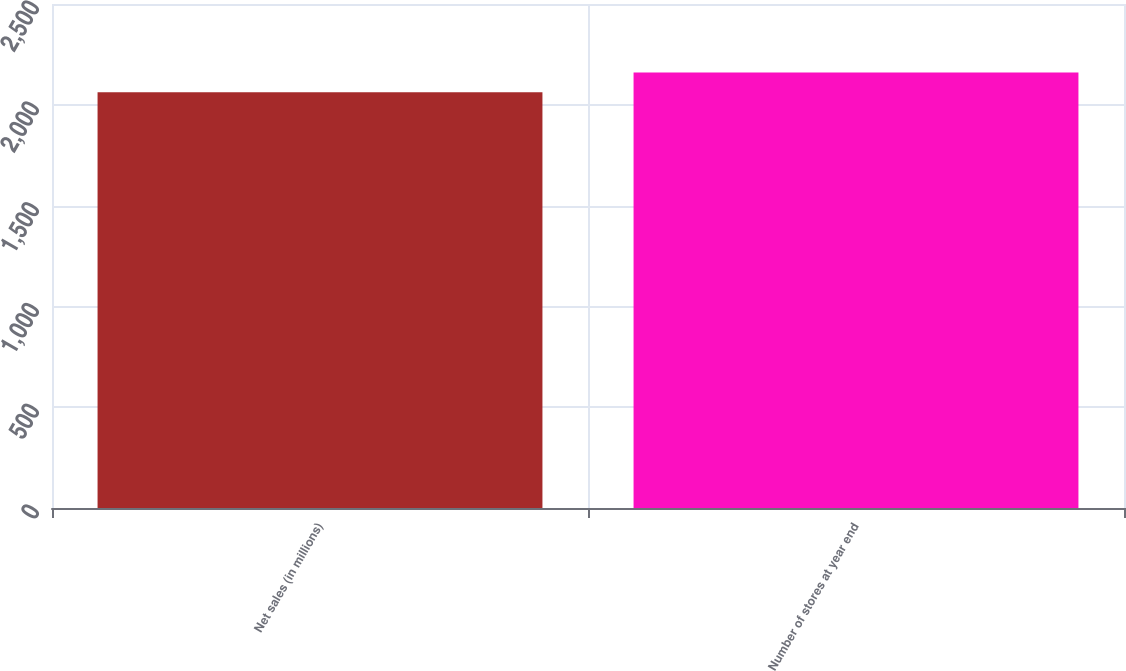Convert chart. <chart><loc_0><loc_0><loc_500><loc_500><bar_chart><fcel>Net sales (in millions)<fcel>Number of stores at year end<nl><fcel>2061.8<fcel>2160<nl></chart> 